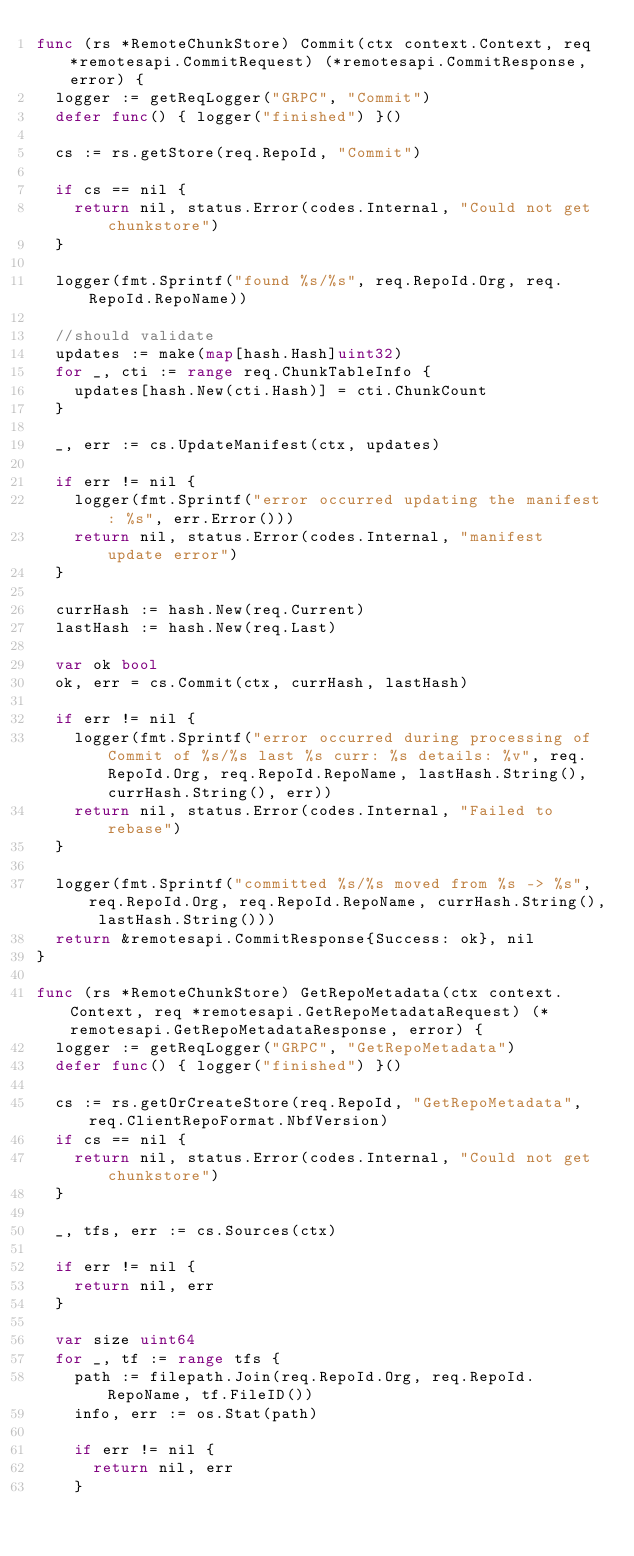Convert code to text. <code><loc_0><loc_0><loc_500><loc_500><_Go_>func (rs *RemoteChunkStore) Commit(ctx context.Context, req *remotesapi.CommitRequest) (*remotesapi.CommitResponse, error) {
	logger := getReqLogger("GRPC", "Commit")
	defer func() { logger("finished") }()

	cs := rs.getStore(req.RepoId, "Commit")

	if cs == nil {
		return nil, status.Error(codes.Internal, "Could not get chunkstore")
	}

	logger(fmt.Sprintf("found %s/%s", req.RepoId.Org, req.RepoId.RepoName))

	//should validate
	updates := make(map[hash.Hash]uint32)
	for _, cti := range req.ChunkTableInfo {
		updates[hash.New(cti.Hash)] = cti.ChunkCount
	}

	_, err := cs.UpdateManifest(ctx, updates)

	if err != nil {
		logger(fmt.Sprintf("error occurred updating the manifest: %s", err.Error()))
		return nil, status.Error(codes.Internal, "manifest update error")
	}

	currHash := hash.New(req.Current)
	lastHash := hash.New(req.Last)

	var ok bool
	ok, err = cs.Commit(ctx, currHash, lastHash)

	if err != nil {
		logger(fmt.Sprintf("error occurred during processing of Commit of %s/%s last %s curr: %s details: %v", req.RepoId.Org, req.RepoId.RepoName, lastHash.String(), currHash.String(), err))
		return nil, status.Error(codes.Internal, "Failed to rebase")
	}

	logger(fmt.Sprintf("committed %s/%s moved from %s -> %s", req.RepoId.Org, req.RepoId.RepoName, currHash.String(), lastHash.String()))
	return &remotesapi.CommitResponse{Success: ok}, nil
}

func (rs *RemoteChunkStore) GetRepoMetadata(ctx context.Context, req *remotesapi.GetRepoMetadataRequest) (*remotesapi.GetRepoMetadataResponse, error) {
	logger := getReqLogger("GRPC", "GetRepoMetadata")
	defer func() { logger("finished") }()

	cs := rs.getOrCreateStore(req.RepoId, "GetRepoMetadata", req.ClientRepoFormat.NbfVersion)
	if cs == nil {
		return nil, status.Error(codes.Internal, "Could not get chunkstore")
	}

	_, tfs, err := cs.Sources(ctx)

	if err != nil {
		return nil, err
	}

	var size uint64
	for _, tf := range tfs {
		path := filepath.Join(req.RepoId.Org, req.RepoId.RepoName, tf.FileID())
		info, err := os.Stat(path)

		if err != nil {
			return nil, err
		}
</code> 